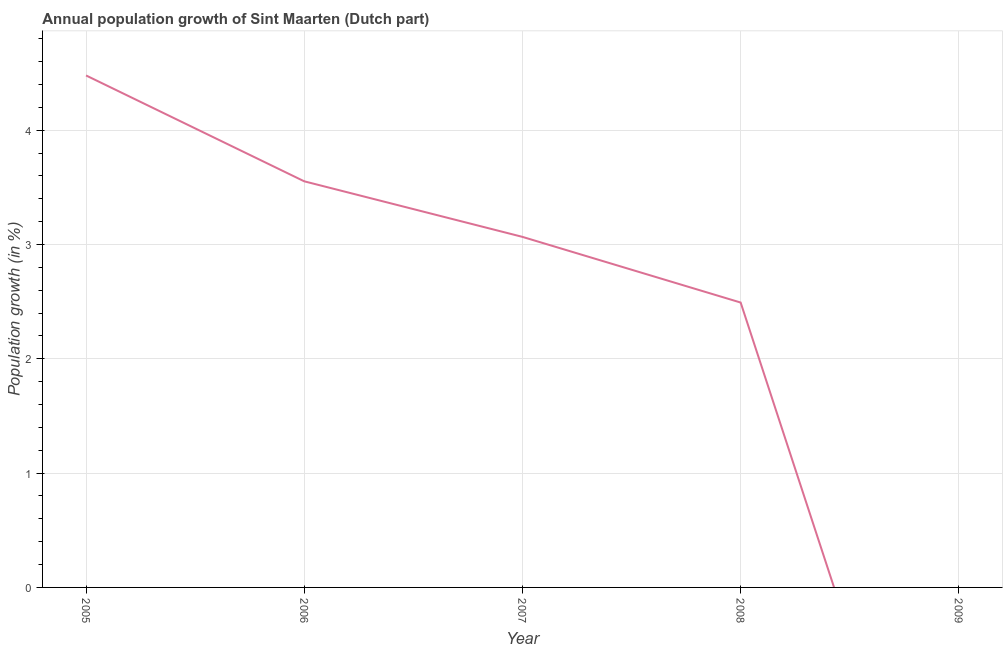What is the population growth in 2006?
Provide a short and direct response. 3.55. Across all years, what is the maximum population growth?
Offer a very short reply. 4.48. Across all years, what is the minimum population growth?
Ensure brevity in your answer.  0. In which year was the population growth maximum?
Make the answer very short. 2005. What is the sum of the population growth?
Give a very brief answer. 13.59. What is the difference between the population growth in 2005 and 2006?
Make the answer very short. 0.93. What is the average population growth per year?
Ensure brevity in your answer.  2.72. What is the median population growth?
Offer a terse response. 3.07. What is the ratio of the population growth in 2006 to that in 2007?
Your response must be concise. 1.16. Is the difference between the population growth in 2005 and 2006 greater than the difference between any two years?
Provide a succinct answer. No. What is the difference between the highest and the second highest population growth?
Offer a terse response. 0.93. Is the sum of the population growth in 2007 and 2008 greater than the maximum population growth across all years?
Ensure brevity in your answer.  Yes. What is the difference between the highest and the lowest population growth?
Give a very brief answer. 4.48. In how many years, is the population growth greater than the average population growth taken over all years?
Make the answer very short. 3. How many lines are there?
Keep it short and to the point. 1. How many years are there in the graph?
Your answer should be very brief. 5. What is the difference between two consecutive major ticks on the Y-axis?
Provide a succinct answer. 1. What is the title of the graph?
Give a very brief answer. Annual population growth of Sint Maarten (Dutch part). What is the label or title of the X-axis?
Your response must be concise. Year. What is the label or title of the Y-axis?
Your answer should be compact. Population growth (in %). What is the Population growth (in %) in 2005?
Offer a very short reply. 4.48. What is the Population growth (in %) in 2006?
Give a very brief answer. 3.55. What is the Population growth (in %) of 2007?
Your response must be concise. 3.07. What is the Population growth (in %) in 2008?
Keep it short and to the point. 2.49. What is the difference between the Population growth (in %) in 2005 and 2006?
Provide a succinct answer. 0.93. What is the difference between the Population growth (in %) in 2005 and 2007?
Ensure brevity in your answer.  1.41. What is the difference between the Population growth (in %) in 2005 and 2008?
Keep it short and to the point. 1.99. What is the difference between the Population growth (in %) in 2006 and 2007?
Offer a terse response. 0.49. What is the difference between the Population growth (in %) in 2006 and 2008?
Offer a terse response. 1.06. What is the difference between the Population growth (in %) in 2007 and 2008?
Provide a succinct answer. 0.57. What is the ratio of the Population growth (in %) in 2005 to that in 2006?
Provide a short and direct response. 1.26. What is the ratio of the Population growth (in %) in 2005 to that in 2007?
Ensure brevity in your answer.  1.46. What is the ratio of the Population growth (in %) in 2005 to that in 2008?
Ensure brevity in your answer.  1.8. What is the ratio of the Population growth (in %) in 2006 to that in 2007?
Offer a very short reply. 1.16. What is the ratio of the Population growth (in %) in 2006 to that in 2008?
Give a very brief answer. 1.43. What is the ratio of the Population growth (in %) in 2007 to that in 2008?
Give a very brief answer. 1.23. 